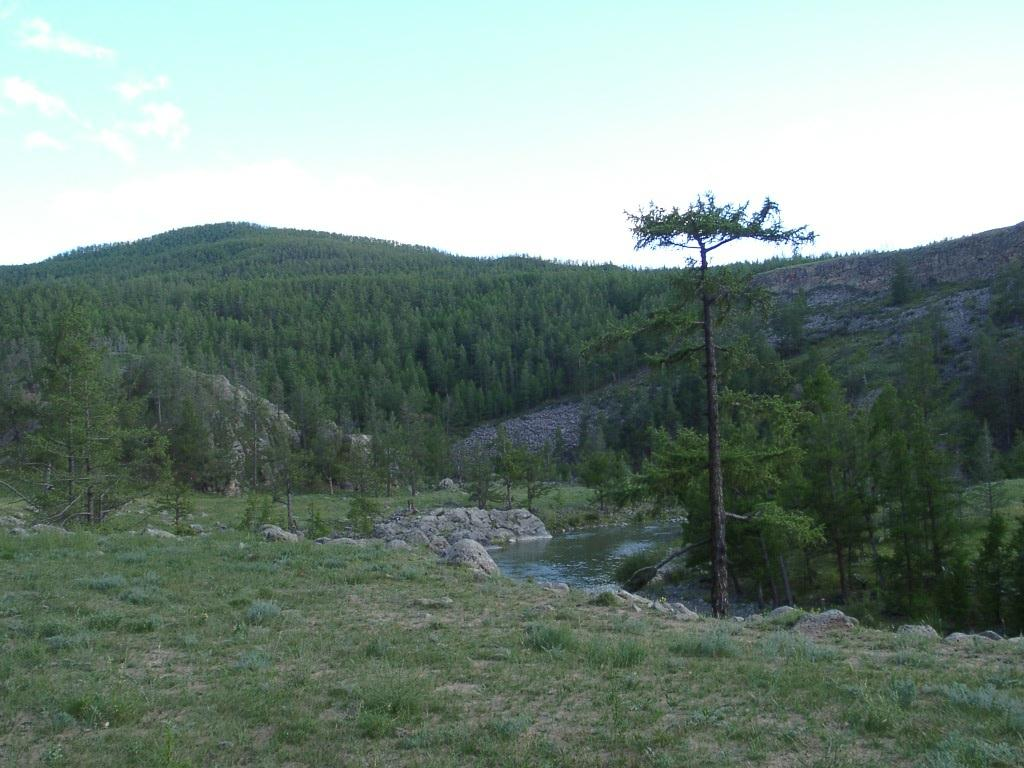What type of vegetation can be seen in the image? There is grass in the image. What else is present in the image besides grass? There is water and trees in the image. What can be seen in the background of the image? The sky is visible in the background of the image. What type of nail is being used to hold the bun in place in the image? There is no bun or nail present in the image; it features grass, water, trees, and the sky. 